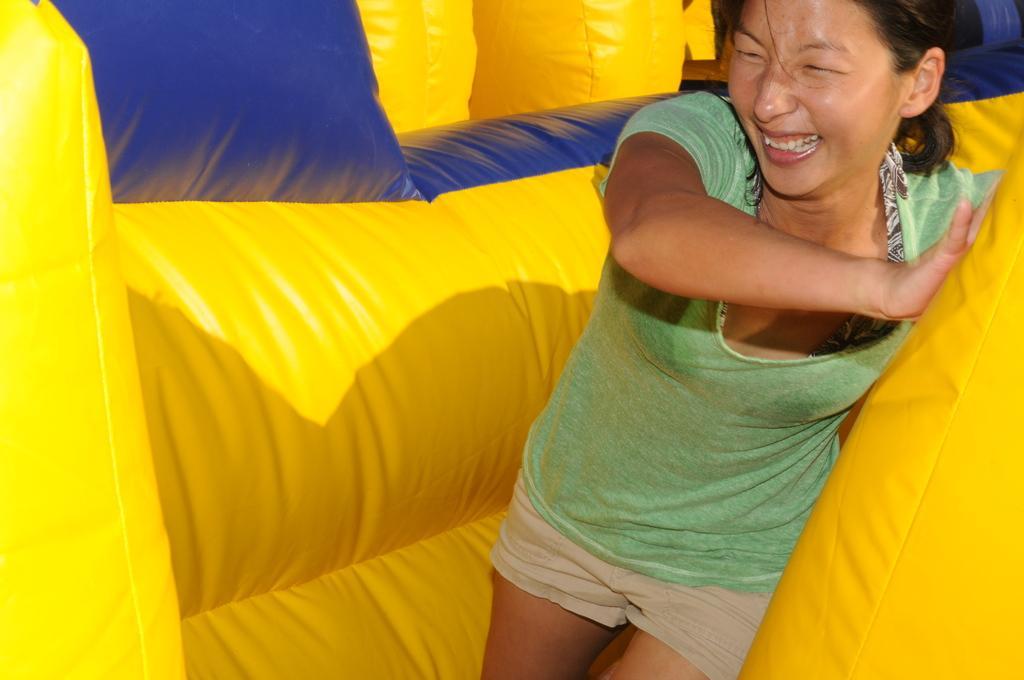In one or two sentences, can you explain what this image depicts? In this picture there is a lady on the right side of the image in an air balloon. 